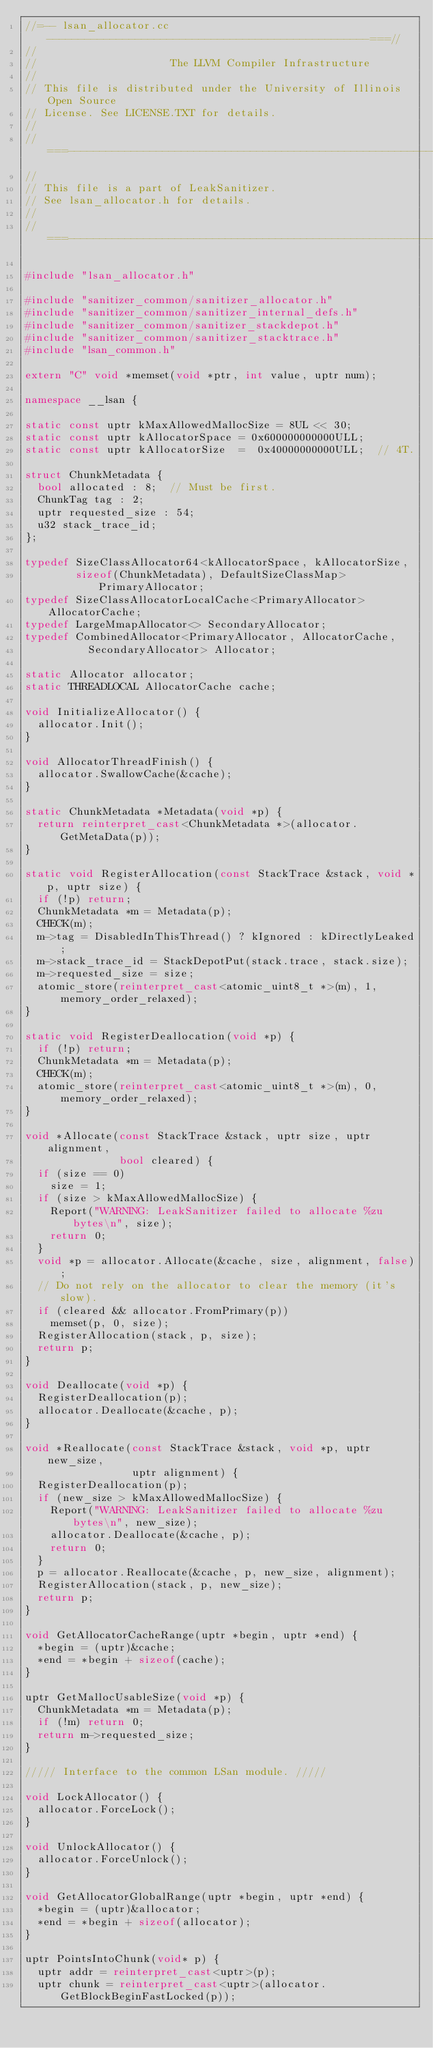Convert code to text. <code><loc_0><loc_0><loc_500><loc_500><_C++_>//=-- lsan_allocator.cc ---------------------------------------------------===//
//
//                     The LLVM Compiler Infrastructure
//
// This file is distributed under the University of Illinois Open Source
// License. See LICENSE.TXT for details.
//
//===----------------------------------------------------------------------===//
//
// This file is a part of LeakSanitizer.
// See lsan_allocator.h for details.
//
//===----------------------------------------------------------------------===//

#include "lsan_allocator.h"

#include "sanitizer_common/sanitizer_allocator.h"
#include "sanitizer_common/sanitizer_internal_defs.h"
#include "sanitizer_common/sanitizer_stackdepot.h"
#include "sanitizer_common/sanitizer_stacktrace.h"
#include "lsan_common.h"

extern "C" void *memset(void *ptr, int value, uptr num);

namespace __lsan {

static const uptr kMaxAllowedMallocSize = 8UL << 30;
static const uptr kAllocatorSpace = 0x600000000000ULL;
static const uptr kAllocatorSize  =  0x40000000000ULL;  // 4T.

struct ChunkMetadata {
  bool allocated : 8;  // Must be first.
  ChunkTag tag : 2;
  uptr requested_size : 54;
  u32 stack_trace_id;
};

typedef SizeClassAllocator64<kAllocatorSpace, kAllocatorSize,
        sizeof(ChunkMetadata), DefaultSizeClassMap> PrimaryAllocator;
typedef SizeClassAllocatorLocalCache<PrimaryAllocator> AllocatorCache;
typedef LargeMmapAllocator<> SecondaryAllocator;
typedef CombinedAllocator<PrimaryAllocator, AllocatorCache,
          SecondaryAllocator> Allocator;

static Allocator allocator;
static THREADLOCAL AllocatorCache cache;

void InitializeAllocator() {
  allocator.Init();
}

void AllocatorThreadFinish() {
  allocator.SwallowCache(&cache);
}

static ChunkMetadata *Metadata(void *p) {
  return reinterpret_cast<ChunkMetadata *>(allocator.GetMetaData(p));
}

static void RegisterAllocation(const StackTrace &stack, void *p, uptr size) {
  if (!p) return;
  ChunkMetadata *m = Metadata(p);
  CHECK(m);
  m->tag = DisabledInThisThread() ? kIgnored : kDirectlyLeaked;
  m->stack_trace_id = StackDepotPut(stack.trace, stack.size);
  m->requested_size = size;
  atomic_store(reinterpret_cast<atomic_uint8_t *>(m), 1, memory_order_relaxed);
}

static void RegisterDeallocation(void *p) {
  if (!p) return;
  ChunkMetadata *m = Metadata(p);
  CHECK(m);
  atomic_store(reinterpret_cast<atomic_uint8_t *>(m), 0, memory_order_relaxed);
}

void *Allocate(const StackTrace &stack, uptr size, uptr alignment,
               bool cleared) {
  if (size == 0)
    size = 1;
  if (size > kMaxAllowedMallocSize) {
    Report("WARNING: LeakSanitizer failed to allocate %zu bytes\n", size);
    return 0;
  }
  void *p = allocator.Allocate(&cache, size, alignment, false);
  // Do not rely on the allocator to clear the memory (it's slow).
  if (cleared && allocator.FromPrimary(p))
    memset(p, 0, size);
  RegisterAllocation(stack, p, size);
  return p;
}

void Deallocate(void *p) {
  RegisterDeallocation(p);
  allocator.Deallocate(&cache, p);
}

void *Reallocate(const StackTrace &stack, void *p, uptr new_size,
                 uptr alignment) {
  RegisterDeallocation(p);
  if (new_size > kMaxAllowedMallocSize) {
    Report("WARNING: LeakSanitizer failed to allocate %zu bytes\n", new_size);
    allocator.Deallocate(&cache, p);
    return 0;
  }
  p = allocator.Reallocate(&cache, p, new_size, alignment);
  RegisterAllocation(stack, p, new_size);
  return p;
}

void GetAllocatorCacheRange(uptr *begin, uptr *end) {
  *begin = (uptr)&cache;
  *end = *begin + sizeof(cache);
}

uptr GetMallocUsableSize(void *p) {
  ChunkMetadata *m = Metadata(p);
  if (!m) return 0;
  return m->requested_size;
}

///// Interface to the common LSan module. /////

void LockAllocator() {
  allocator.ForceLock();
}

void UnlockAllocator() {
  allocator.ForceUnlock();
}

void GetAllocatorGlobalRange(uptr *begin, uptr *end) {
  *begin = (uptr)&allocator;
  *end = *begin + sizeof(allocator);
}

uptr PointsIntoChunk(void* p) {
  uptr addr = reinterpret_cast<uptr>(p);
  uptr chunk = reinterpret_cast<uptr>(allocator.GetBlockBeginFastLocked(p));</code> 